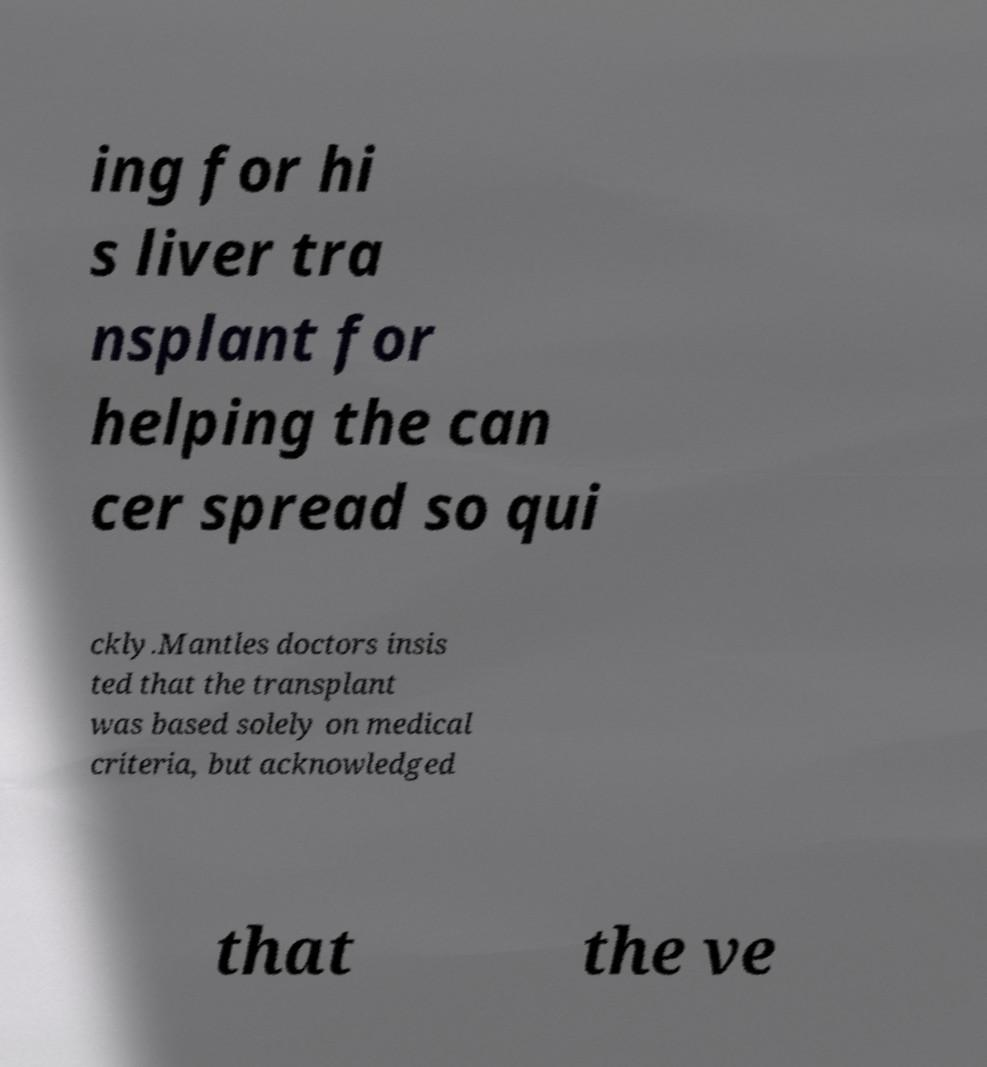There's text embedded in this image that I need extracted. Can you transcribe it verbatim? ing for hi s liver tra nsplant for helping the can cer spread so qui ckly.Mantles doctors insis ted that the transplant was based solely on medical criteria, but acknowledged that the ve 